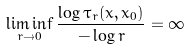Convert formula to latex. <formula><loc_0><loc_0><loc_500><loc_500>\liminf _ { r \rightarrow 0 } \frac { \log \tau _ { r } ( x , x _ { 0 } ) } { - \log r } = \infty</formula> 